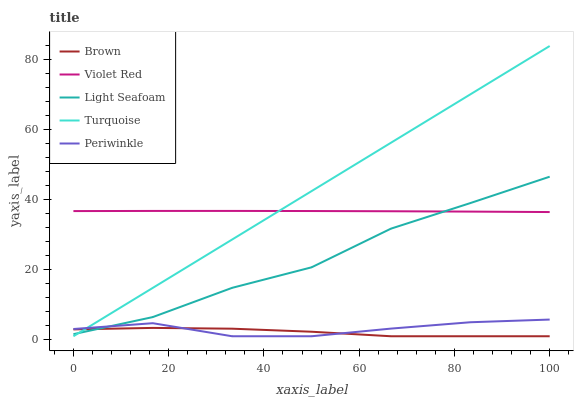Does Violet Red have the minimum area under the curve?
Answer yes or no. No. Does Violet Red have the maximum area under the curve?
Answer yes or no. No. Is Violet Red the smoothest?
Answer yes or no. No. Is Violet Red the roughest?
Answer yes or no. No. Does Light Seafoam have the lowest value?
Answer yes or no. No. Does Violet Red have the highest value?
Answer yes or no. No. Is Brown less than Violet Red?
Answer yes or no. Yes. Is Violet Red greater than Periwinkle?
Answer yes or no. Yes. Does Brown intersect Violet Red?
Answer yes or no. No. 